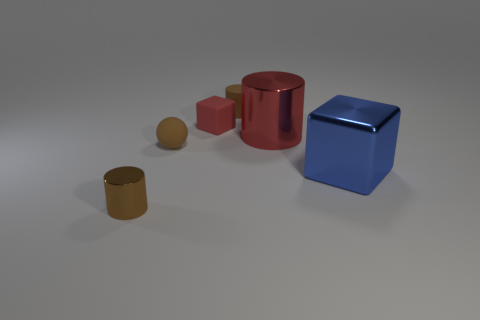What material is the tiny brown thing behind the tiny rubber sphere?
Give a very brief answer. Rubber. There is a brown matte object that is the same shape as the red metal object; what is its size?
Offer a terse response. Small. Is the number of tiny brown balls behind the tiny ball less than the number of metallic cubes?
Your answer should be compact. Yes. Is there a tiny brown cube?
Your answer should be compact. No. What color is the matte thing that is the same shape as the brown metal thing?
Keep it short and to the point. Brown. Is the color of the cylinder behind the tiny red matte object the same as the ball?
Your response must be concise. Yes. Is the size of the red shiny object the same as the blue cube?
Offer a terse response. Yes. The red object that is the same material as the small brown sphere is what shape?
Give a very brief answer. Cube. How many other objects are there of the same shape as the big red object?
Ensure brevity in your answer.  2. There is a large object that is in front of the brown rubber thing that is in front of the small red rubber cube right of the brown metallic cylinder; what is its shape?
Provide a short and direct response. Cube. 